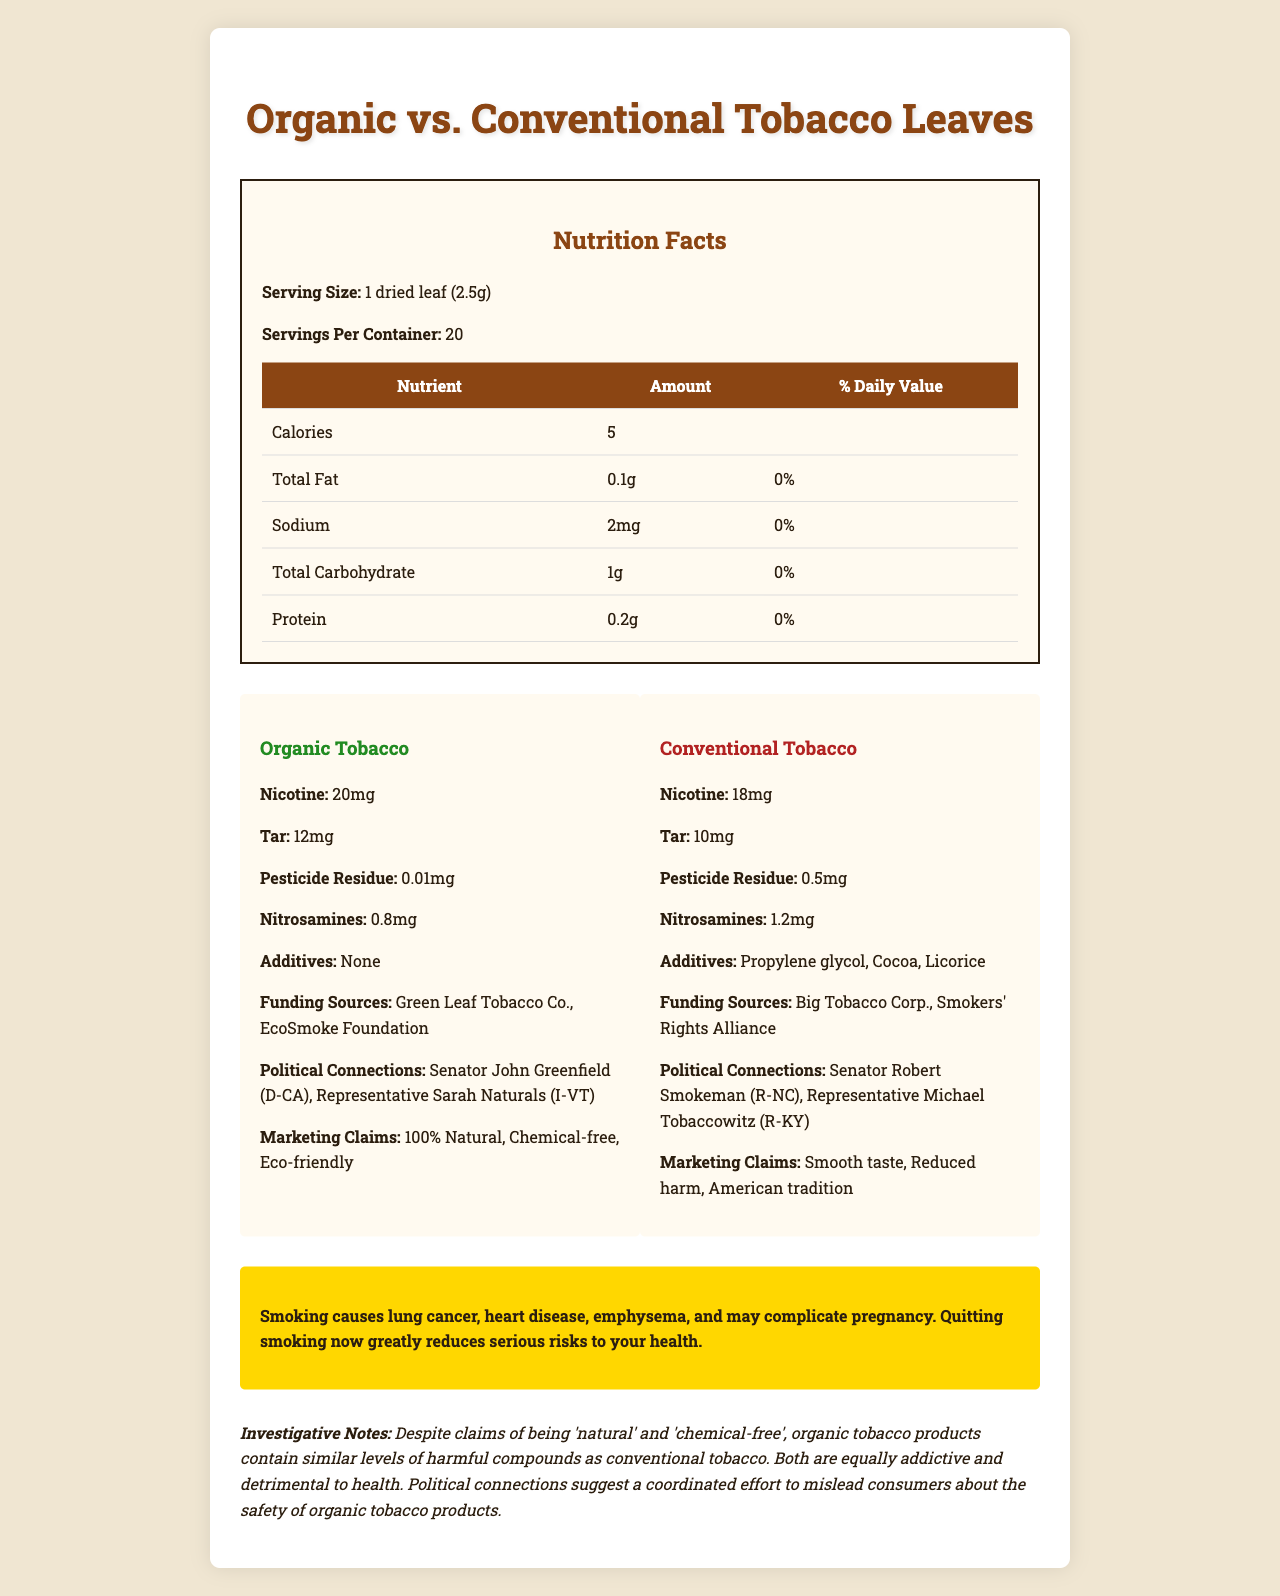who are the funding sources for organic tobacco? The funding sources for organic tobacco products are explicitly listed as Green Leaf Tobacco Co. and EcoSmoke Foundation.
Answer: Green Leaf Tobacco Co., EcoSmoke Foundation what is the nicotine content in conventional tobacco leaves? The nicotine content for conventional tobacco leaves is given as 18mg in the document.
Answer: 18mg how much sodium is in a serving size? The sodium content per serving size is listed as 2mg in the document.
Answer: 2mg what additives are found in conventional tobacco? The document lists the additives in conventional tobacco as Propylene glycol, Cocoa, and Licorice.
Answer: Propylene glycol, Cocoa, Licorice which type of tobacco has more tar per serving? Organic tobacco has 12mg of tar per serving, whereas conventional tobacco has 10mg of tar per serving.
Answer: Organic tobacco which political figure is associated with organic tobacco funding? The document lists Senator John Greenfield (D-CA) as being politically connected to organic tobacco funding.
Answer: Senator John Greenfield (D-CA) what health warning is associated with the tobacco products? The document includes a health warning that states smoking causes lung cancer, heart disease, emphysema, and may complicate pregnancy. It also notes that quitting smoking now greatly reduces serious risks to your health.
Answer: Smoking causes lung cancer, heart disease, emphysema, and may complicate pregnancy. Quitting smoking now greatly reduces serious risks to your health. how much pesticide residue is found in organic tobacco? The pesticide residue amount in organic tobacco is indicated as 0.01mg in the document.
Answer: 0.01mg which has higher nitrosamine content, organic or conventional tobacco? A. Organic B. Conventional C. Both are equal The conventional tobacco has a higher nitrosamine content (1.2mg) compared to organic tobacco (0.8mg).
Answer: B. Conventional who is associated with funding conventional tobacco? 1. Senator Robert Smokeman 2. Representative Michael Tobaccowitz 3. Representative Sarah Naturals 4. Both 1 and 2 The document lists both Senator Robert Smokeman (R-NC) and Representative Michael Tobaccowitz (R-KY) as being connected to conventional tobacco funding.
Answer: 4. Both 1 and 2 is there a significant difference in nicotine content between organic and conventional tobacco? Organic tobacco contains 20mg of nicotine, whereas conventional tobacco contains 18mg. This shows that organic tobacco has slightly higher nicotine content.
Answer: Yes summarize the nutritional differences and similarities between organic and conventional tobacco. The document highlights that while organic and conventional tobacco share similar nutritional components like calories, fat, sodium, carbohydrates, and protein, they differ in harmful components where organic tobacco has more nicotine and tar but fewer pesticide residues and nitrosamines compared to conventional tobacco. Additionally, organic tobacco lacks additives found in conventional tobacco.
Answer: Both organic and conventional tobacco products have similar basic nutritional content such as calories, fat, sodium, carbohydrates, and protein. However, organic tobacco has higher nicotine and tar but significantly lower pesticide residue and slightly lower nitrosamines compared to conventional tobacco. who endorsed the marketing claims of these tobacco products? The document lists the marketing claims for each tobacco product but does not provide any information on who endorsed these claims.
Answer: Not enough information 